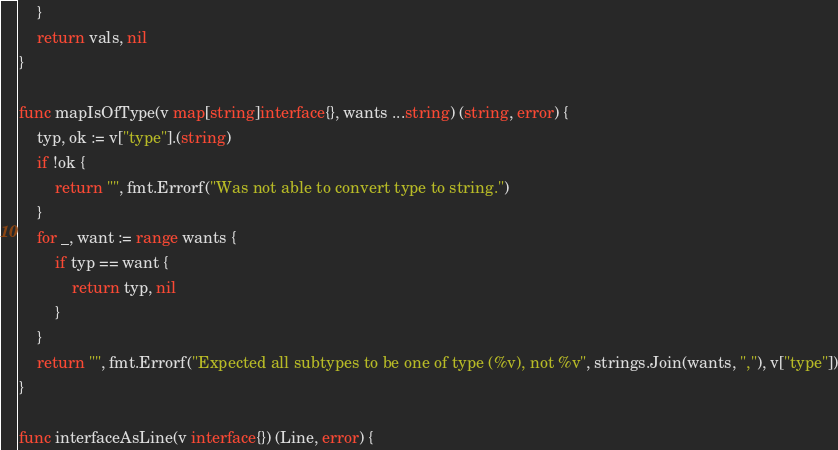<code> <loc_0><loc_0><loc_500><loc_500><_Go_>	}
	return vals, nil
}

func mapIsOfType(v map[string]interface{}, wants ...string) (string, error) {
	typ, ok := v["type"].(string)
	if !ok {
		return "", fmt.Errorf("Was not able to convert type to string.")
	}
	for _, want := range wants {
		if typ == want {
			return typ, nil
		}
	}
	return "", fmt.Errorf("Expected all subtypes to be one of type (%v), not %v", strings.Join(wants, ","), v["type"])
}

func interfaceAsLine(v interface{}) (Line, error) {</code> 